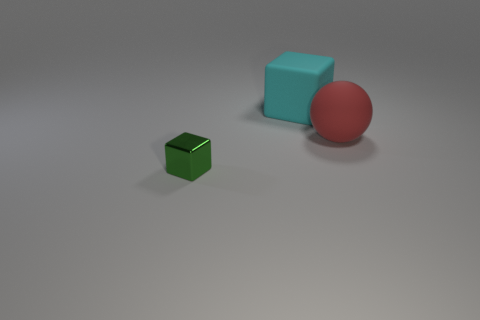Are the cyan thing and the thing in front of the ball made of the same material?
Keep it short and to the point. No. Are there any big cyan matte blocks in front of the matte sphere?
Offer a terse response. No. What number of objects are red shiny blocks or matte things that are on the right side of the large cyan rubber object?
Your answer should be compact. 1. The block behind the thing that is on the left side of the large cyan thing is what color?
Your answer should be compact. Cyan. What number of other objects are the same material as the large cyan object?
Provide a succinct answer. 1. How many shiny objects are large brown objects or tiny green cubes?
Your response must be concise. 1. What color is the large matte thing that is the same shape as the small shiny thing?
Your answer should be very brief. Cyan. What number of things are either large shiny cylinders or cubes?
Your response must be concise. 2. There is a red object that is the same material as the big cyan object; what is its shape?
Offer a terse response. Sphere. How many big objects are matte things or cyan things?
Make the answer very short. 2. 